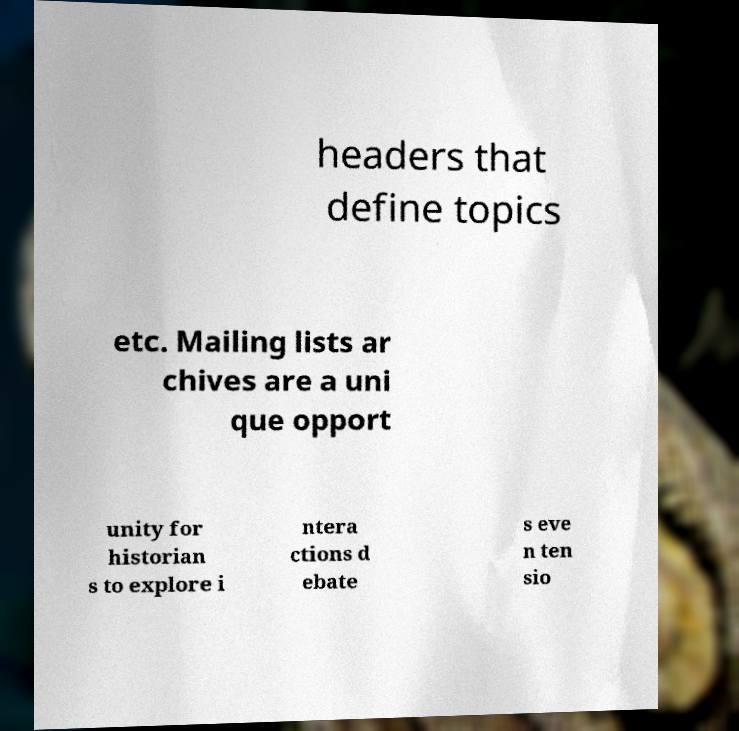Can you read and provide the text displayed in the image?This photo seems to have some interesting text. Can you extract and type it out for me? headers that define topics etc. Mailing lists ar chives are a uni que opport unity for historian s to explore i ntera ctions d ebate s eve n ten sio 